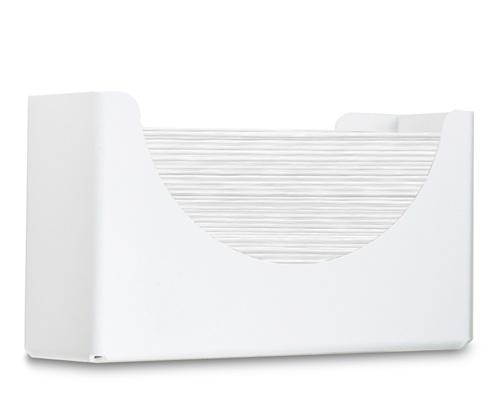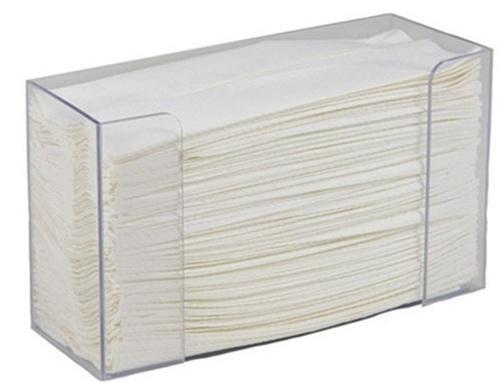The first image is the image on the left, the second image is the image on the right. For the images shown, is this caption "Each image shows a rectangular tray-type container holding a stack of folded paper towels." true? Answer yes or no. Yes. The first image is the image on the left, the second image is the image on the right. For the images shown, is this caption "Both dispensers are rectangular in shape." true? Answer yes or no. Yes. 